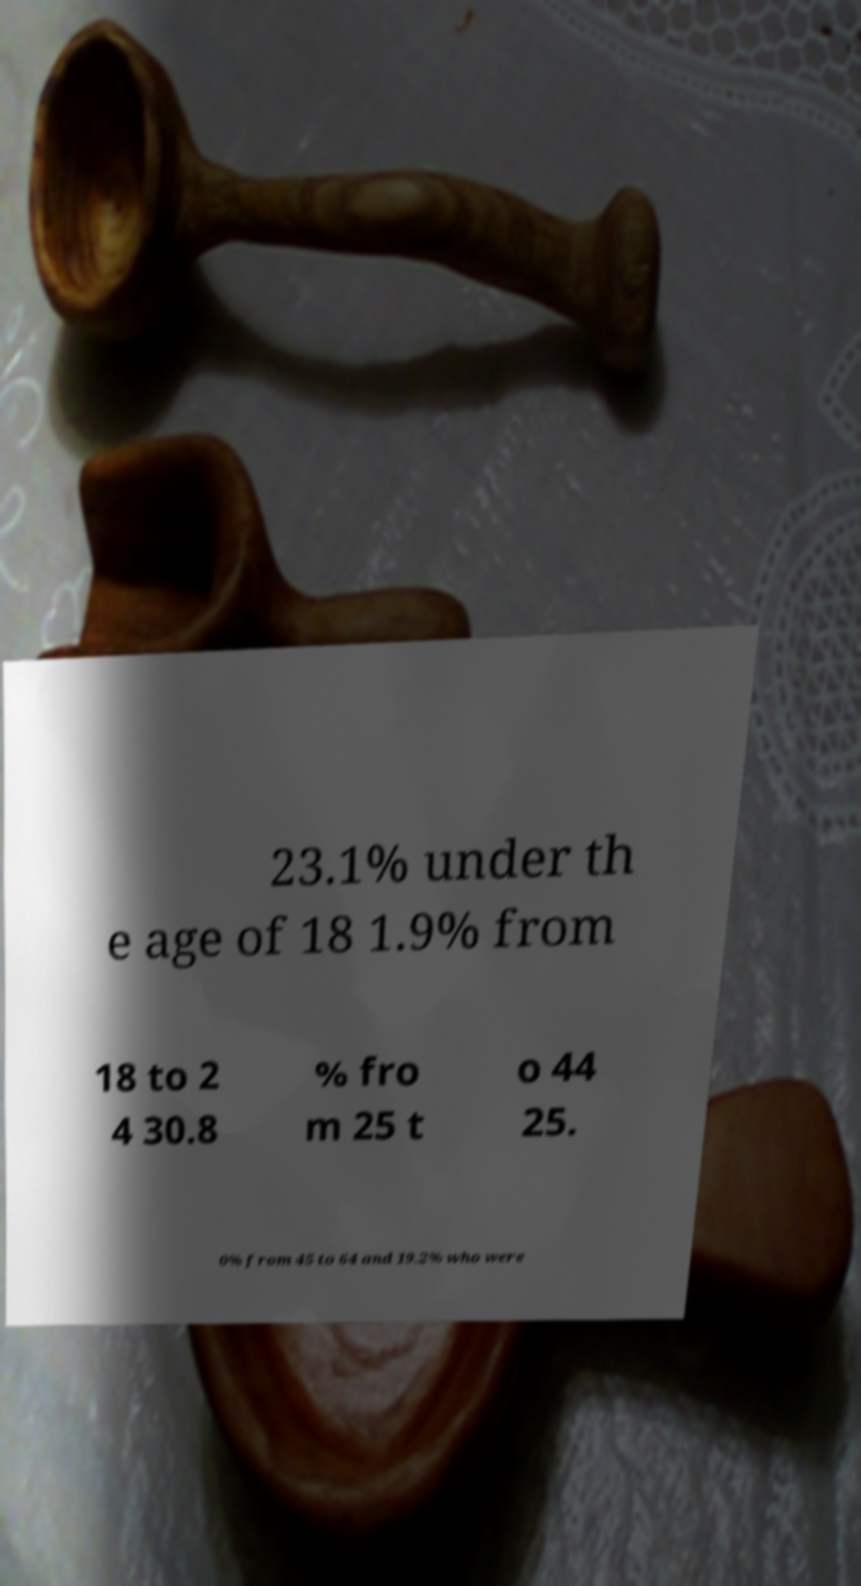There's text embedded in this image that I need extracted. Can you transcribe it verbatim? 23.1% under th e age of 18 1.9% from 18 to 2 4 30.8 % fro m 25 t o 44 25. 0% from 45 to 64 and 19.2% who were 